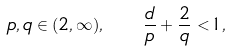Convert formula to latex. <formula><loc_0><loc_0><loc_500><loc_500>p , q \in ( 2 , \infty ) , \quad \frac { d } { p } + \frac { 2 } { q } < 1 ,</formula> 